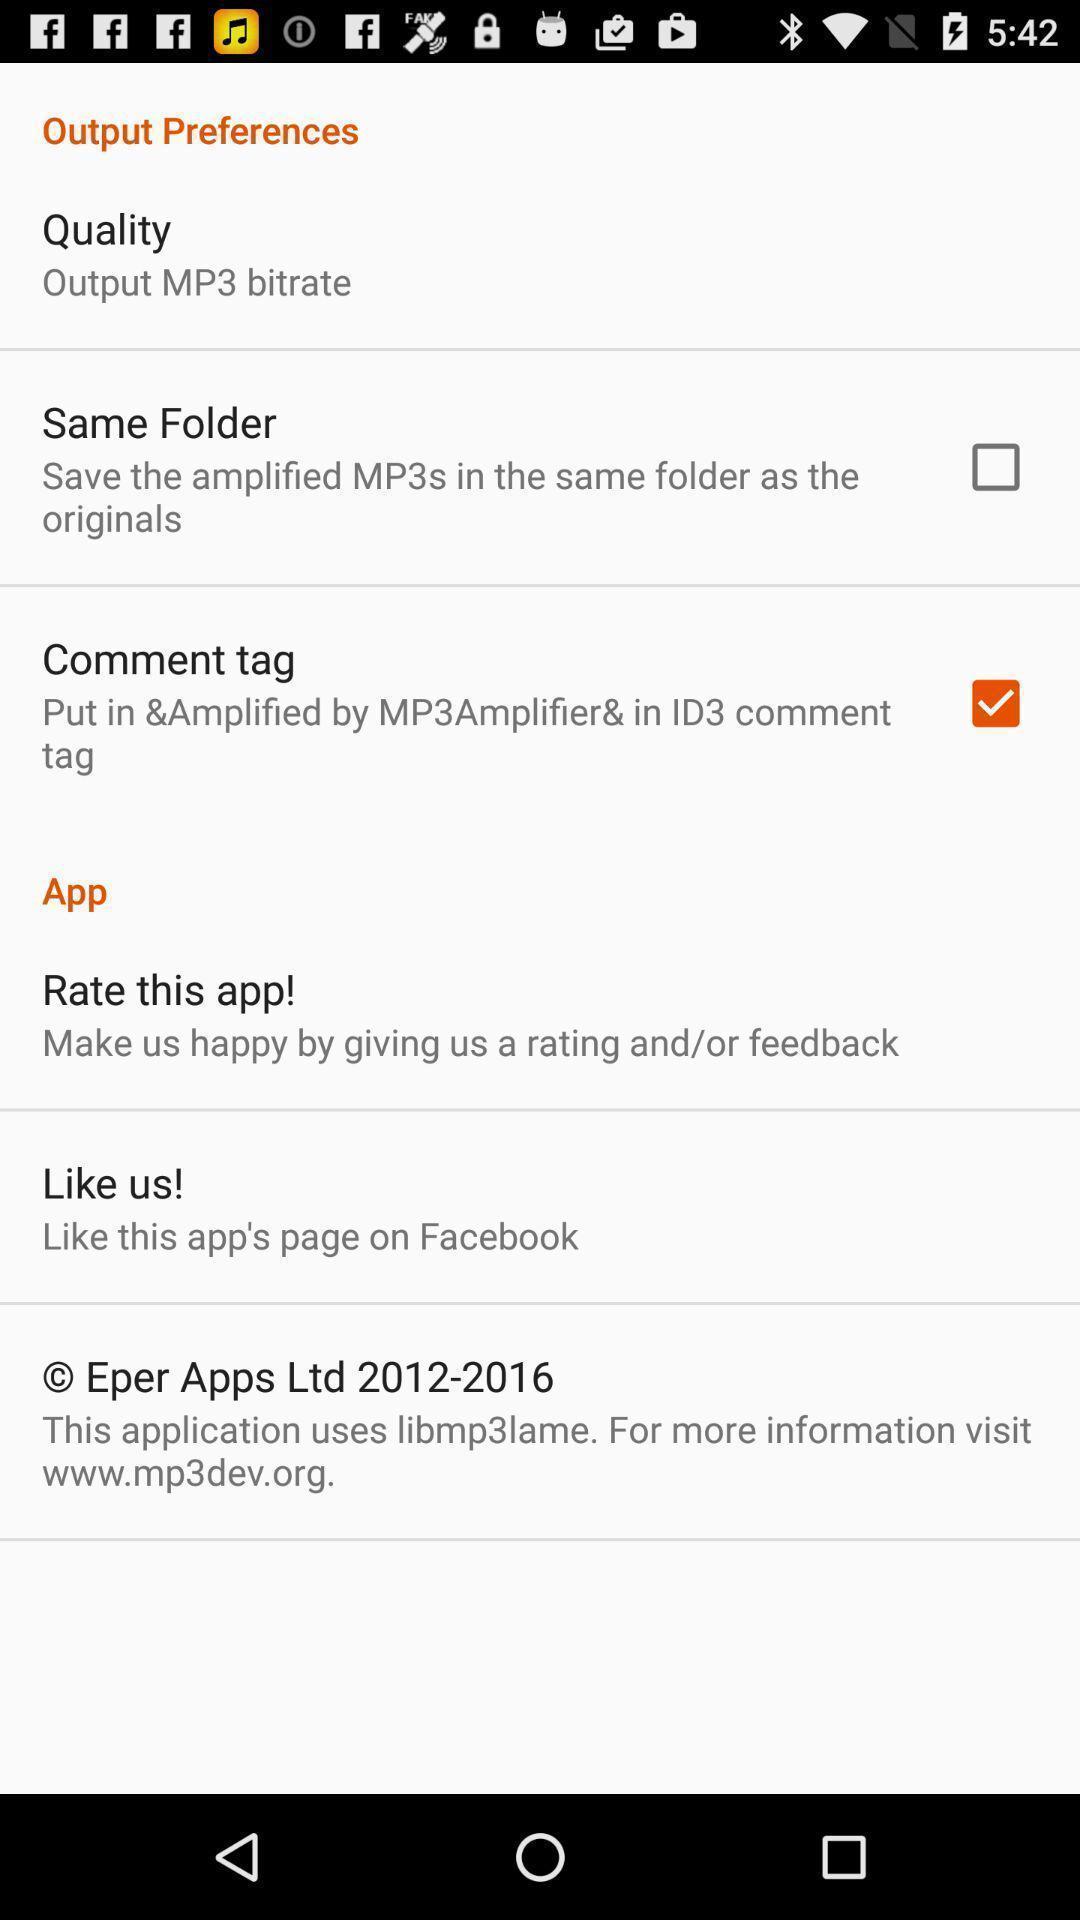Give me a narrative description of this picture. Screen displaying preference settings page. 